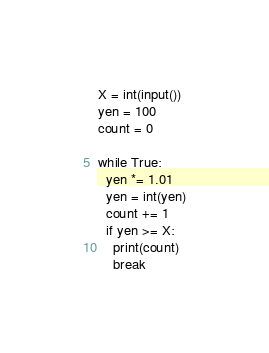Convert code to text. <code><loc_0><loc_0><loc_500><loc_500><_Python_>X = int(input())
yen = 100
count = 0

while True:
  yen *= 1.01
  yen = int(yen)
  count += 1
  if yen >= X:
    print(count)
    break</code> 